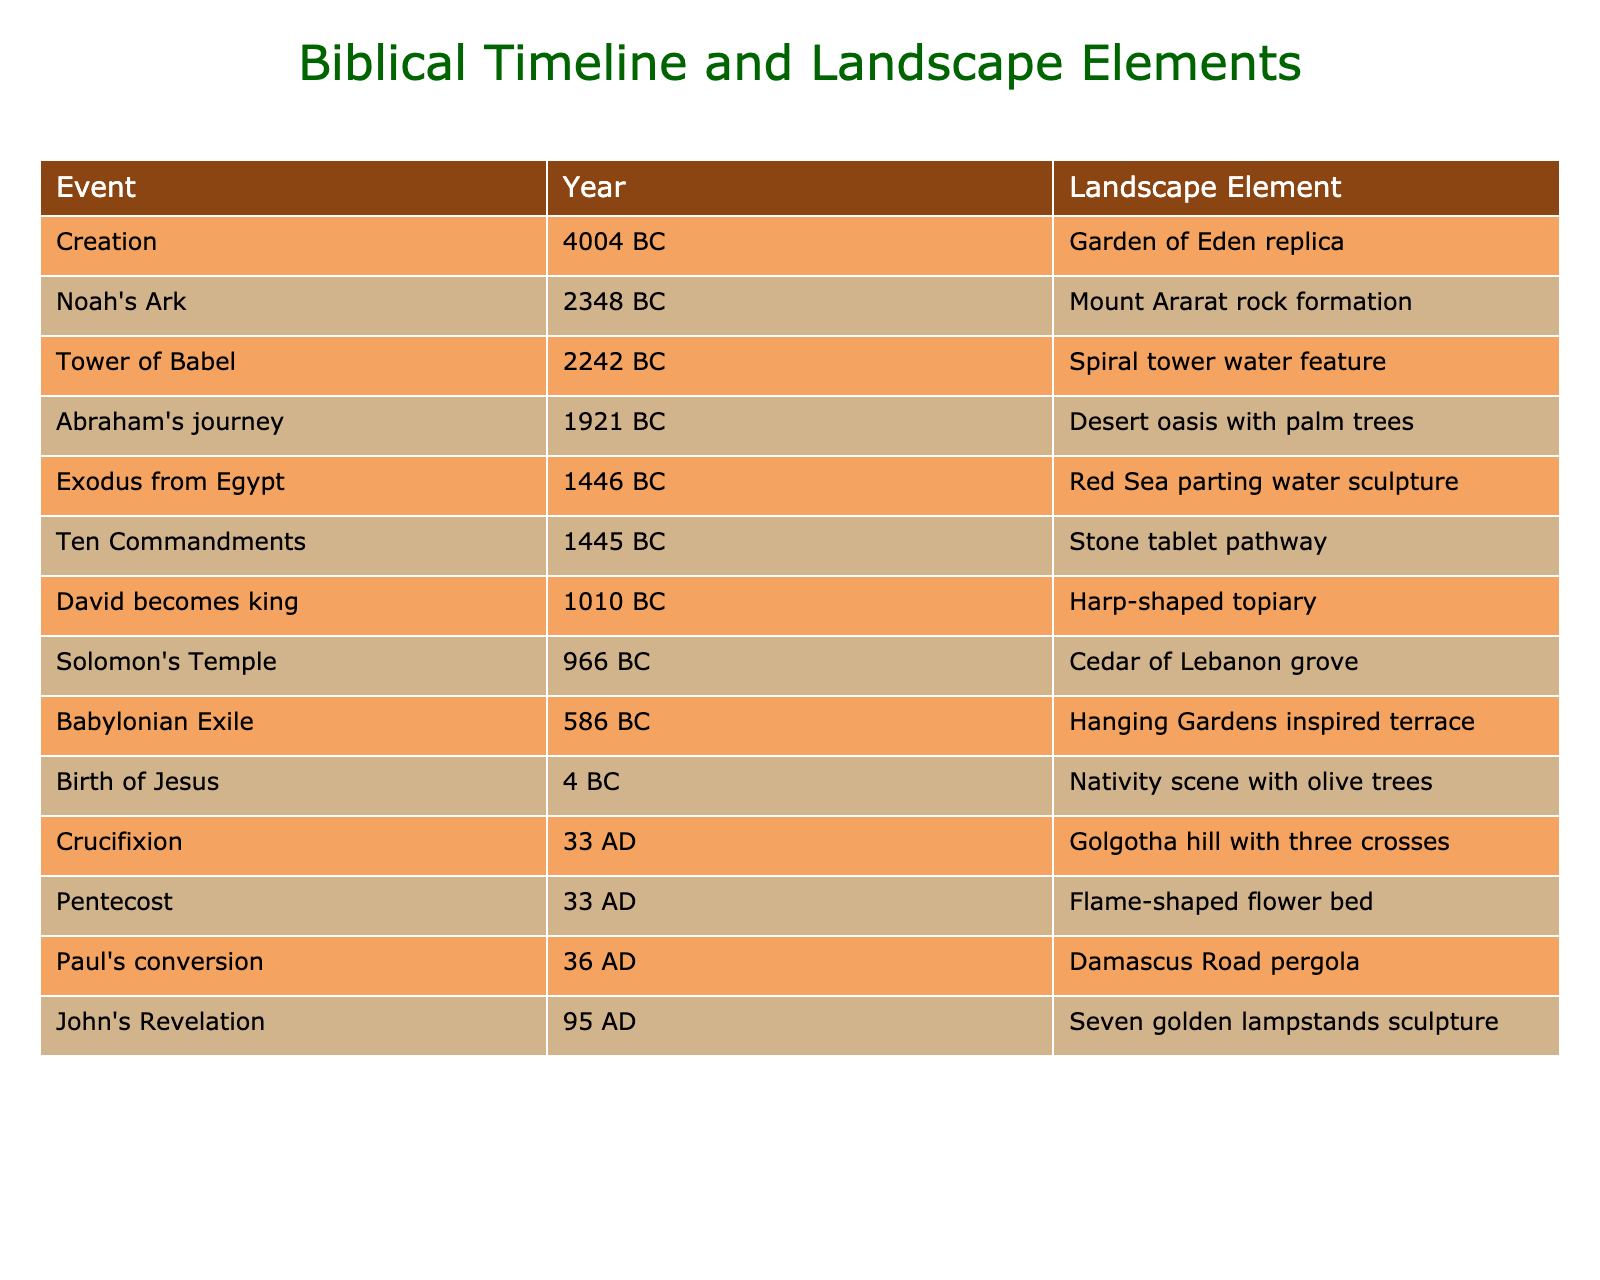What is the landscape element associated with the Crucifixion? According to the table, the landscape element for the Crucifixion event is the "Golgotha hill with three crosses."
Answer: Golgotha hill with three crosses In which year did the Tower of Babel occur? The table states that the Tower of Babel event took place in 2242 BC.
Answer: 2242 BC How many events occurred before the birth of Jesus? By counting the events listed before the Birth of Jesus in the table, there are 10 events (from Creation to the Birth of Jesus).
Answer: 10 What is the difference in years between the Exodus from Egypt and the Birth of Jesus? The Exodus from Egypt occurred in 1446 BC and the Birth of Jesus in 4 BC. The difference is 1446 + 4 = 1450 years.
Answer: 1450 years Is there a landscape element mentioned for the event of Paul's conversion? Yes, the table shows that the landscape element for Paul's conversion is the "Damascus Road pergola."
Answer: Yes What are the landscape elements from the events that occurred in the 1st century AD? The events in the 1st century AD include the Crucifixion and Pentecost. Their corresponding landscape elements are "Golgotha hill with three crosses" and "Flame-shaped flower bed."
Answer: Golgotha hill with three crosses and Flame-shaped flower bed Which event has a landscape element inspired by the Hanging Gardens? The Babylonian Exile corresponds to a landscape element inspired by the Hanging Gardens, which is noted in the table.
Answer: Babylonian Exile Are there any events listed that take place in the year 33 AD? Yes, both the Crucifixion and Pentecost events are listed for 33 AD in the table.
Answer: Yes What is the average year of events in the 1st millennium BC (from 1000 BC to 1 BC)? There are 8 events listed from 1010 BC to 1 BC. The average is calculated by taking the sum of the years: (1010 + 966 + 586 + 4) / 4 = 641.5, which involves adding the four years and dividing by 4.
Answer: 641.5 Which event occurred closest to the year 0? The table indicates that the Birth of Jesus happened in 4 BC, making it the event closest to the year 0.
Answer: Birth of Jesus 